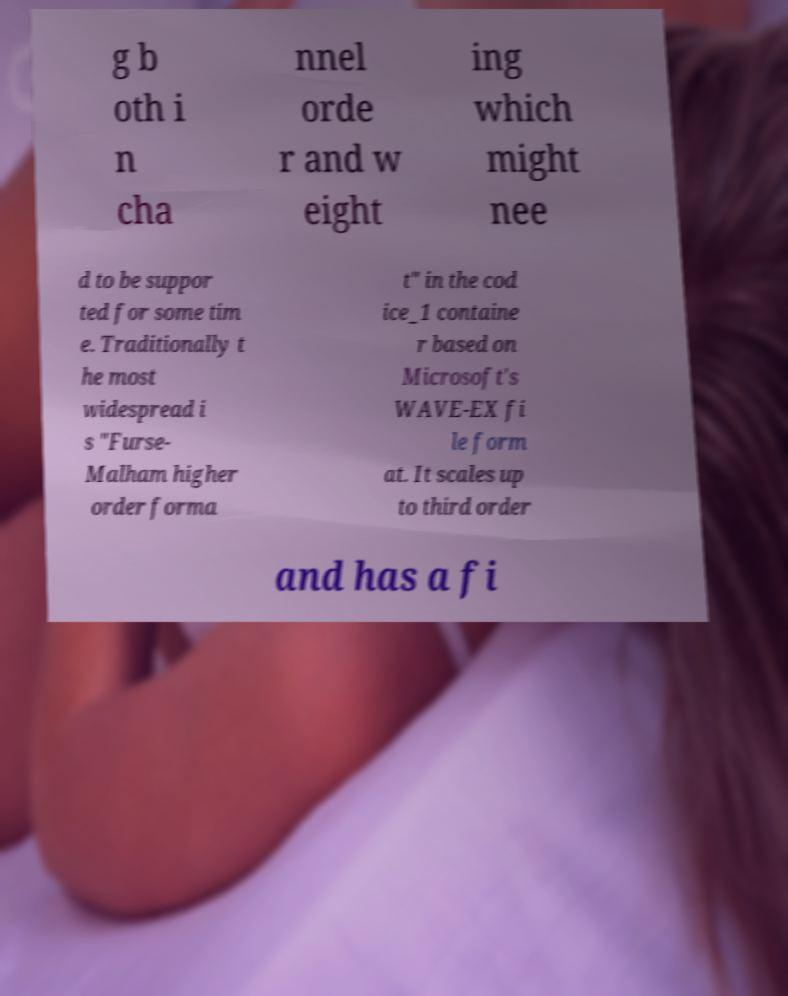Can you accurately transcribe the text from the provided image for me? g b oth i n cha nnel orde r and w eight ing which might nee d to be suppor ted for some tim e. Traditionally t he most widespread i s "Furse- Malham higher order forma t" in the cod ice_1 containe r based on Microsoft's WAVE-EX fi le form at. It scales up to third order and has a fi 